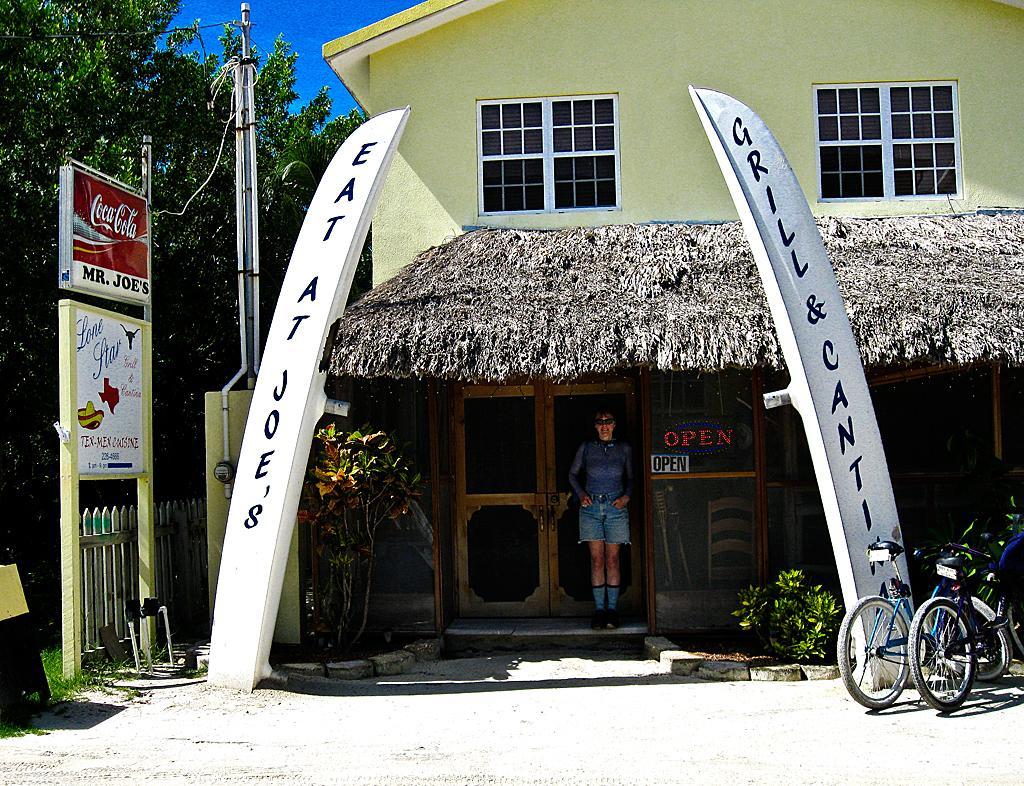Could you give a brief overview of what you see in this image? In this image we can see a person standing at the door of a building. There are bicycles on the right side of this image and there is a pole, boats and a tree on the left side of this image. And there is a blue sky in the background. 